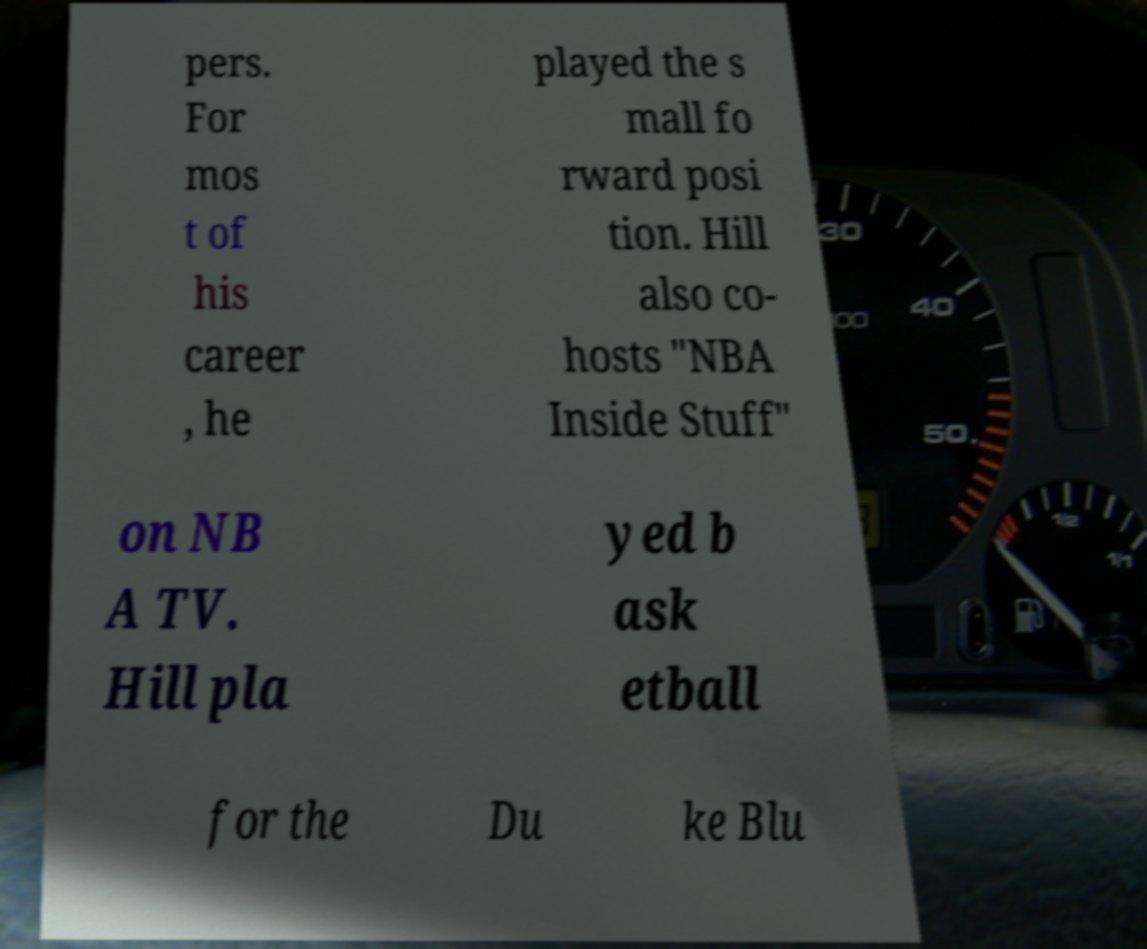What messages or text are displayed in this image? I need them in a readable, typed format. pers. For mos t of his career , he played the s mall fo rward posi tion. Hill also co- hosts "NBA Inside Stuff" on NB A TV. Hill pla yed b ask etball for the Du ke Blu 